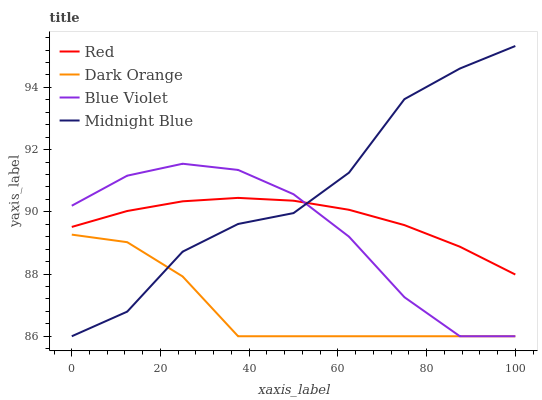Does Dark Orange have the minimum area under the curve?
Answer yes or no. Yes. Does Midnight Blue have the maximum area under the curve?
Answer yes or no. Yes. Does Blue Violet have the minimum area under the curve?
Answer yes or no. No. Does Blue Violet have the maximum area under the curve?
Answer yes or no. No. Is Red the smoothest?
Answer yes or no. Yes. Is Midnight Blue the roughest?
Answer yes or no. Yes. Is Blue Violet the smoothest?
Answer yes or no. No. Is Blue Violet the roughest?
Answer yes or no. No. Does Dark Orange have the lowest value?
Answer yes or no. Yes. Does Red have the lowest value?
Answer yes or no. No. Does Midnight Blue have the highest value?
Answer yes or no. Yes. Does Blue Violet have the highest value?
Answer yes or no. No. Is Dark Orange less than Red?
Answer yes or no. Yes. Is Red greater than Dark Orange?
Answer yes or no. Yes. Does Midnight Blue intersect Red?
Answer yes or no. Yes. Is Midnight Blue less than Red?
Answer yes or no. No. Is Midnight Blue greater than Red?
Answer yes or no. No. Does Dark Orange intersect Red?
Answer yes or no. No. 